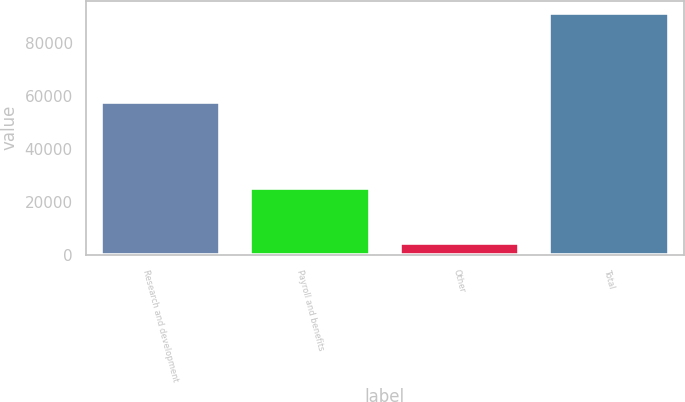<chart> <loc_0><loc_0><loc_500><loc_500><bar_chart><fcel>Research and development<fcel>Payroll and benefits<fcel>Other<fcel>Total<nl><fcel>57761<fcel>25115<fcel>4635<fcel>91359<nl></chart> 